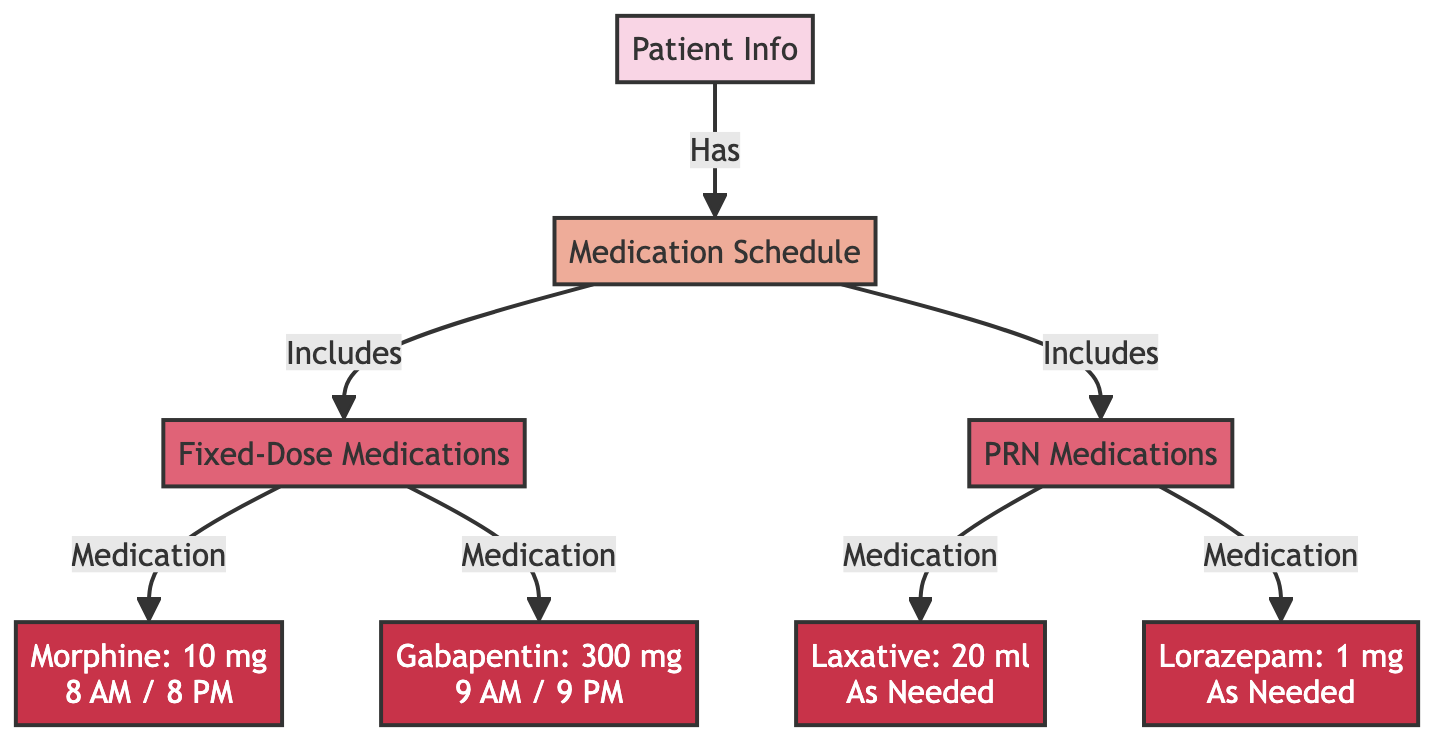What are the fixed-dose medications listed in the diagram? The diagram specifically indicates two fixed-dose medications under the 'Fixed-Dose Medications' category: Morphine and Gabapentin.
Answer: Morphine, Gabapentin How many PRN medications are included in the medication schedule? In the diagram, there are two medications categorized as PRN (as needed): Laxative and Lorazepam, making a total of two PRN medications.
Answer: 2 What time is Morphine administered according to the schedule? The diagram clearly states that Morphine is administered at 8 AM and 8 PM, illustrating the schedule for this medication.
Answer: 8 AM / 8 PM How many total medication types are represented in the schedule? The diagram includes four total medication types: two fixed-dose (Morphine and Gabapentin) and two PRN medications (Laxative and Lorazepam), resulting in a total of four medication types.
Answer: 4 Which medication can be taken as needed? According to the diagram, both Laxative and Lorazepam are labeled as PRN medications, meaning they can be taken as needed. The first listed PRN medication that indicates this is Laxative.
Answer: Laxative What is the dosage for Gabapentin? From the diagram, Gabapentin is indicated with a dosage of 300 mg, which appears in the 'Fixed-Dose Medications' section.
Answer: 300 mg Which class of medications in the diagram requires a fixed dosing schedule? The 'Fixed-Dose Medications' class in the diagram, which includes Morphine and Gabapentin, specifically requires a fixed dosing schedule.
Answer: Fixed-Dose Medications What is the relationship between patient info and medication schedule? The diagram illustrates a direct link where the Patient Info node points to the Medication Schedule, indicating that the patient has a medication schedule in place.
Answer: Has 